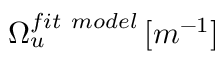<formula> <loc_0><loc_0><loc_500><loc_500>\Omega _ { u } ^ { f i t \ m o d e l } \, [ m ^ { - 1 } ]</formula> 